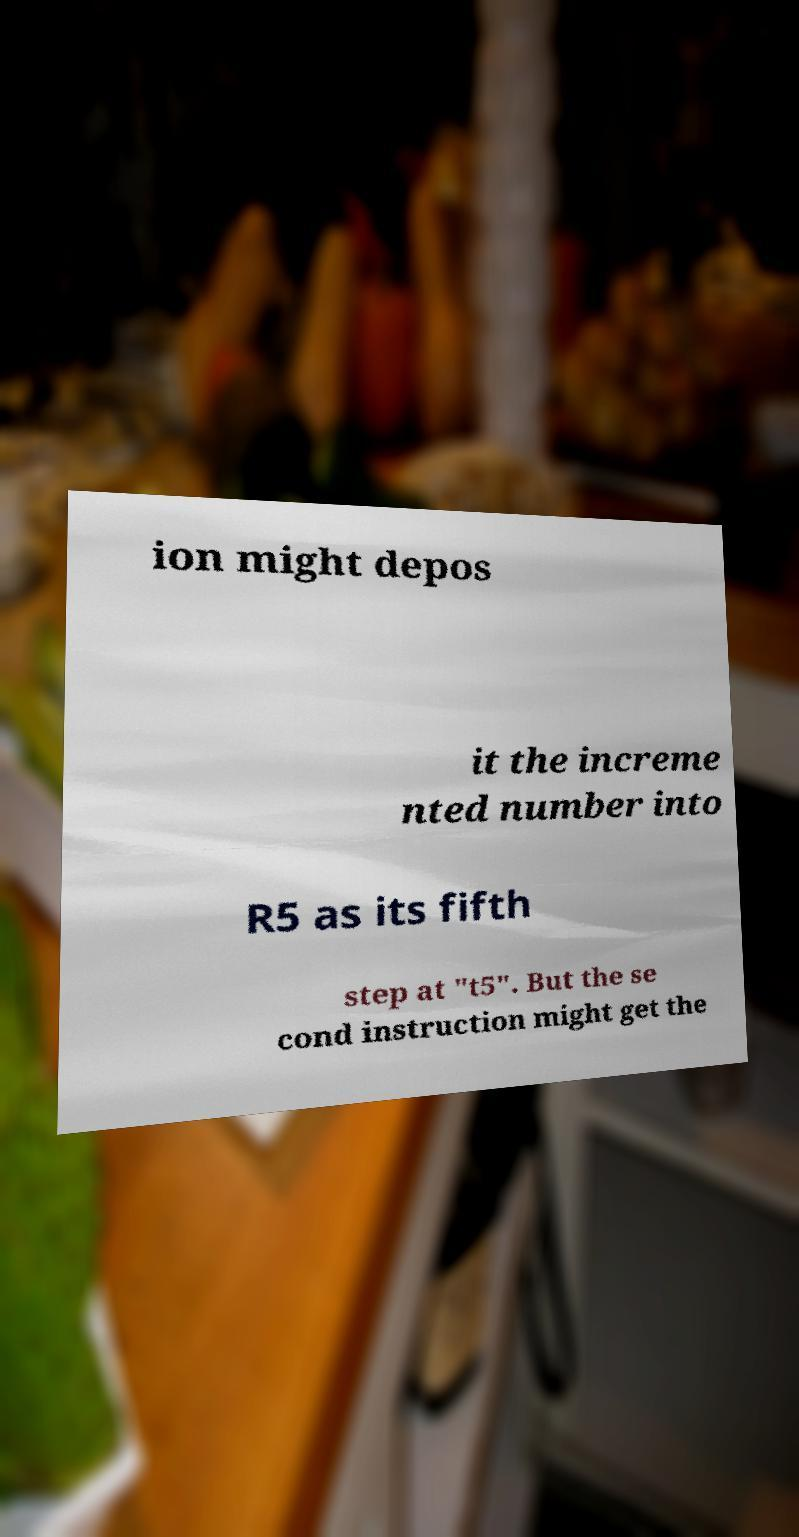Could you assist in decoding the text presented in this image and type it out clearly? ion might depos it the increme nted number into R5 as its fifth step at "t5". But the se cond instruction might get the 